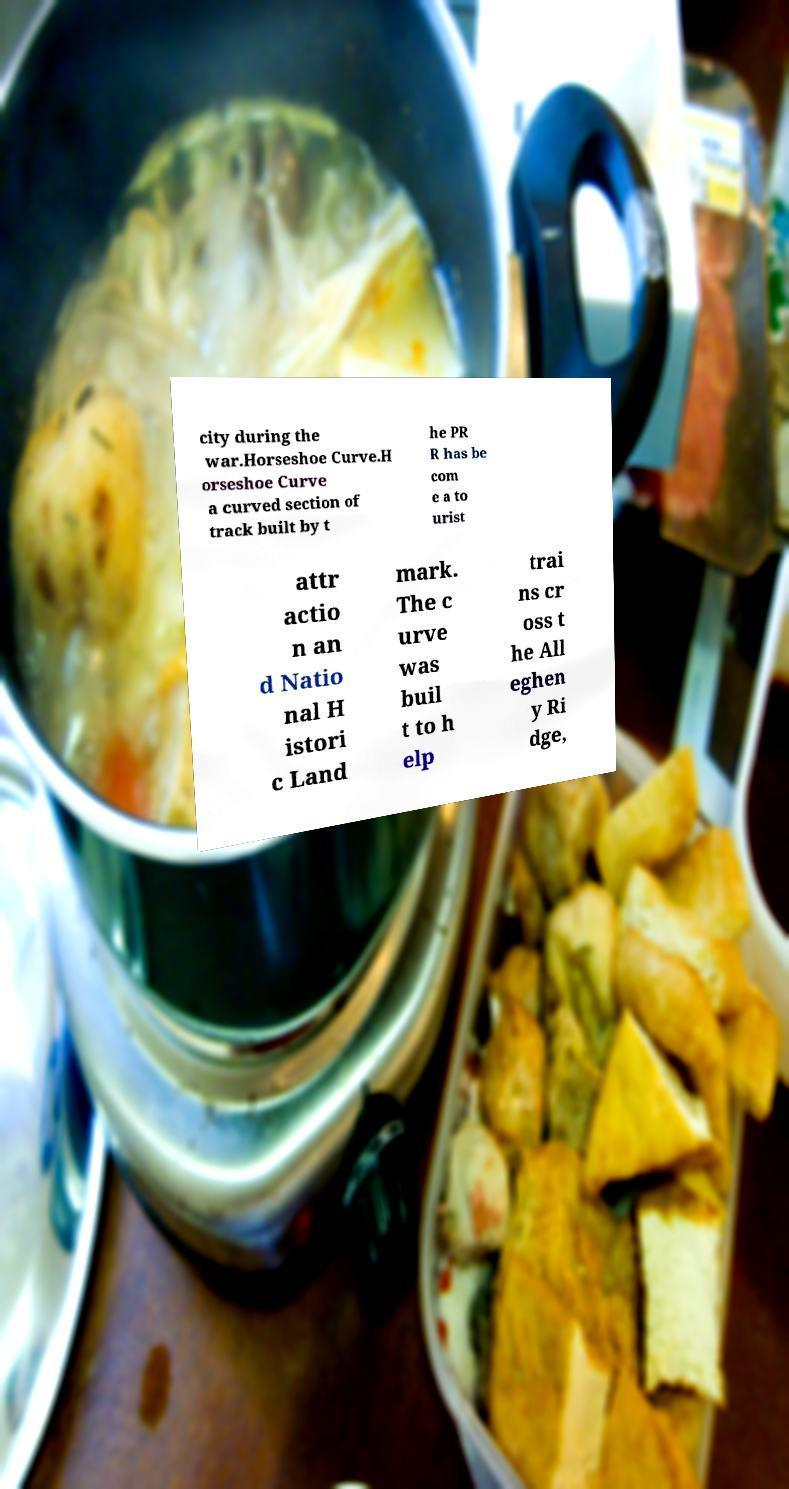Can you accurately transcribe the text from the provided image for me? city during the war.Horseshoe Curve.H orseshoe Curve a curved section of track built by t he PR R has be com e a to urist attr actio n an d Natio nal H istori c Land mark. The c urve was buil t to h elp trai ns cr oss t he All eghen y Ri dge, 